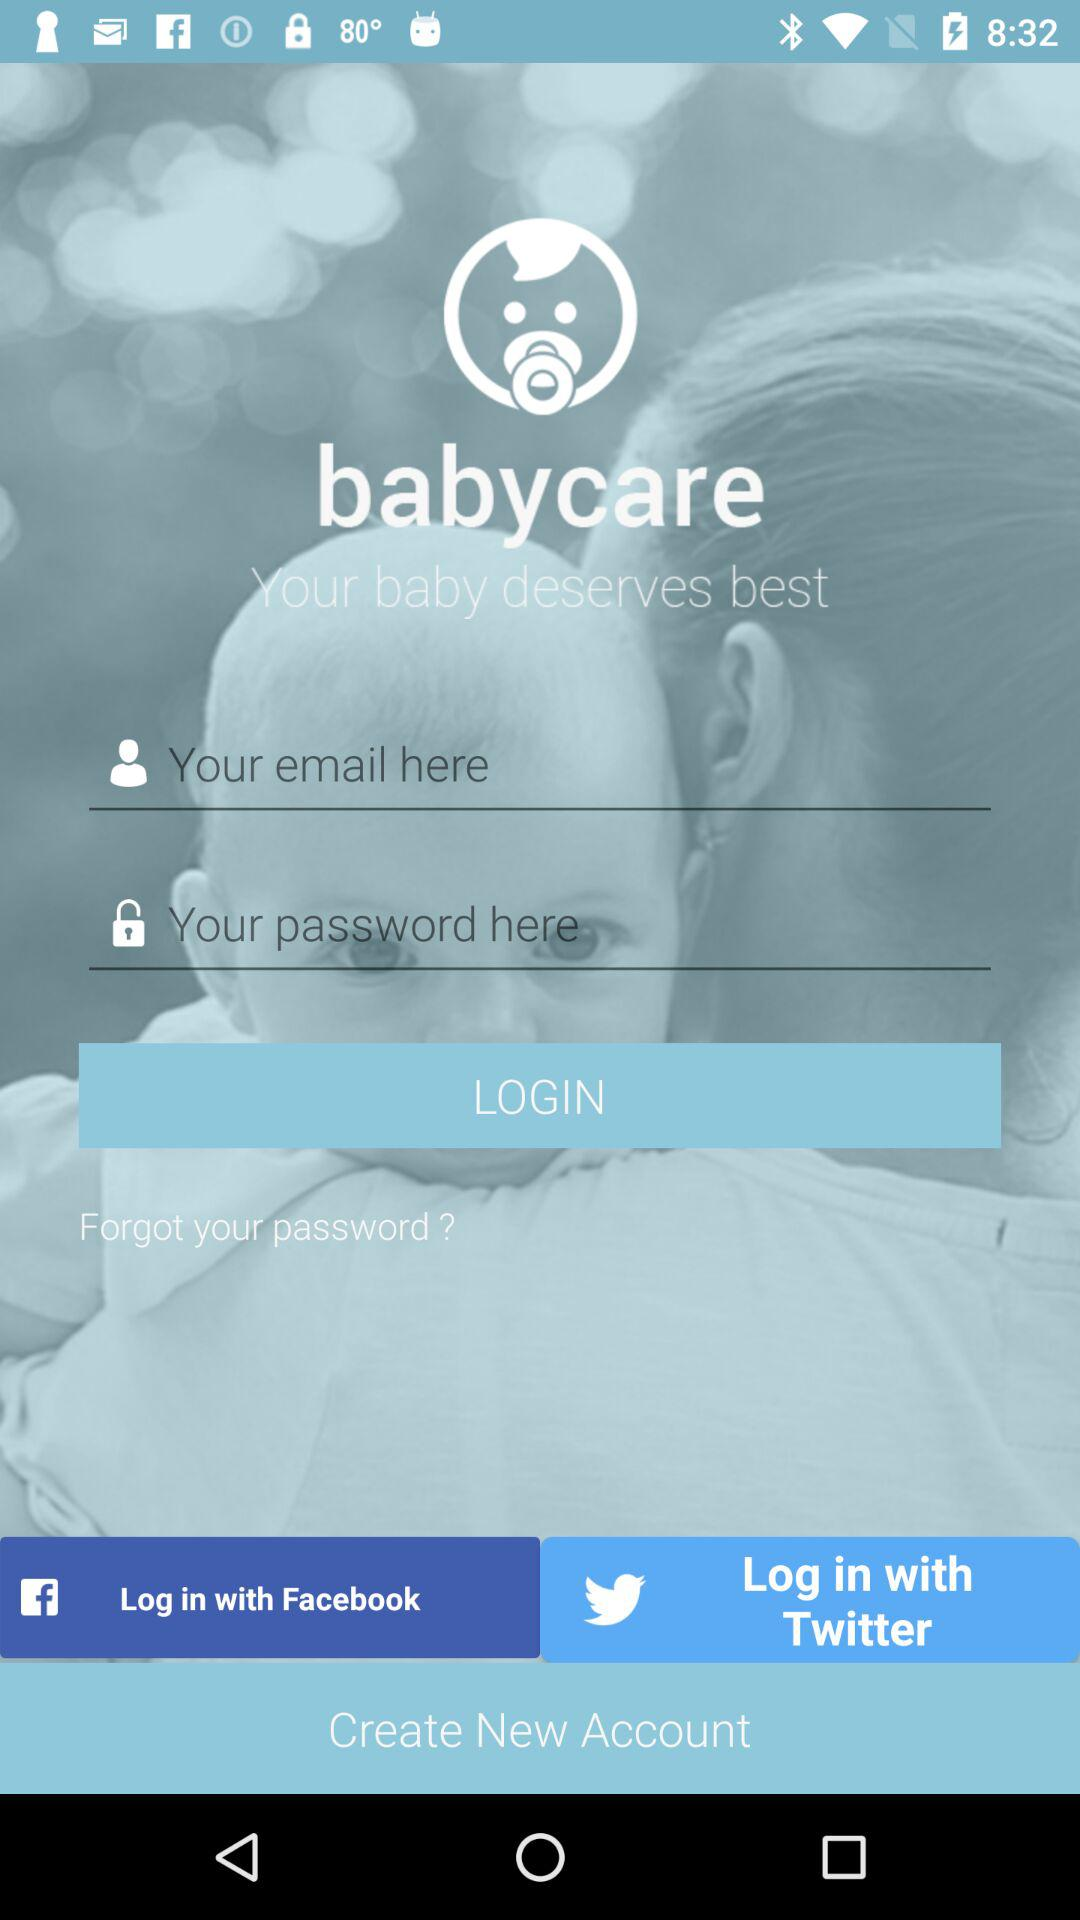What are the requirements to login? The requirements to login are email and password. 